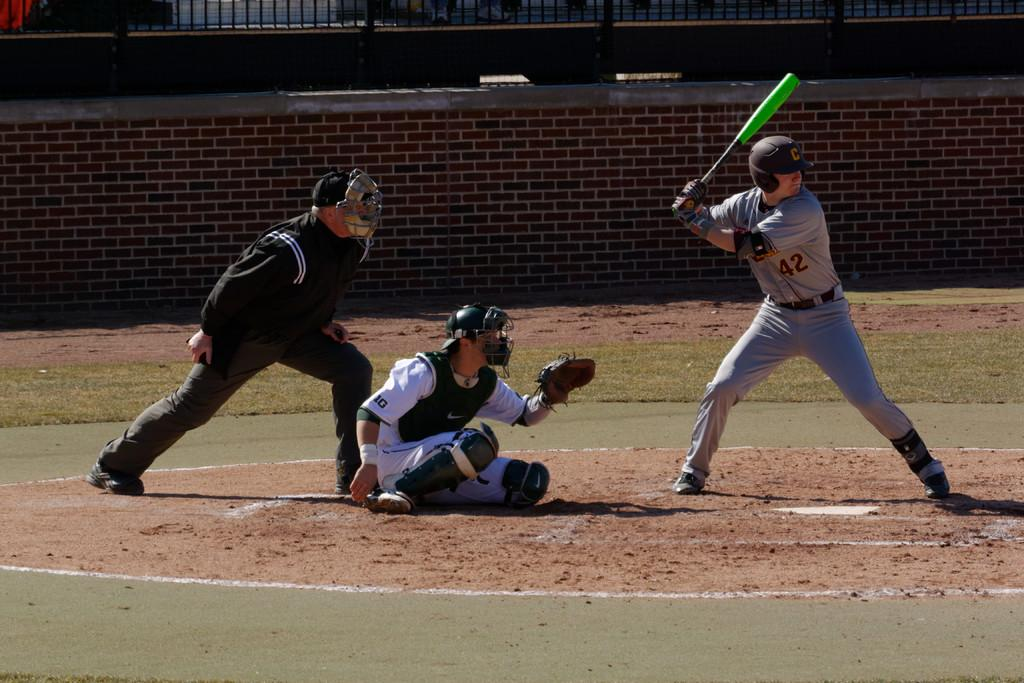<image>
Summarize the visual content of the image. Player number 42 getting ready to swing at a pitch to try to hit a baseball. 